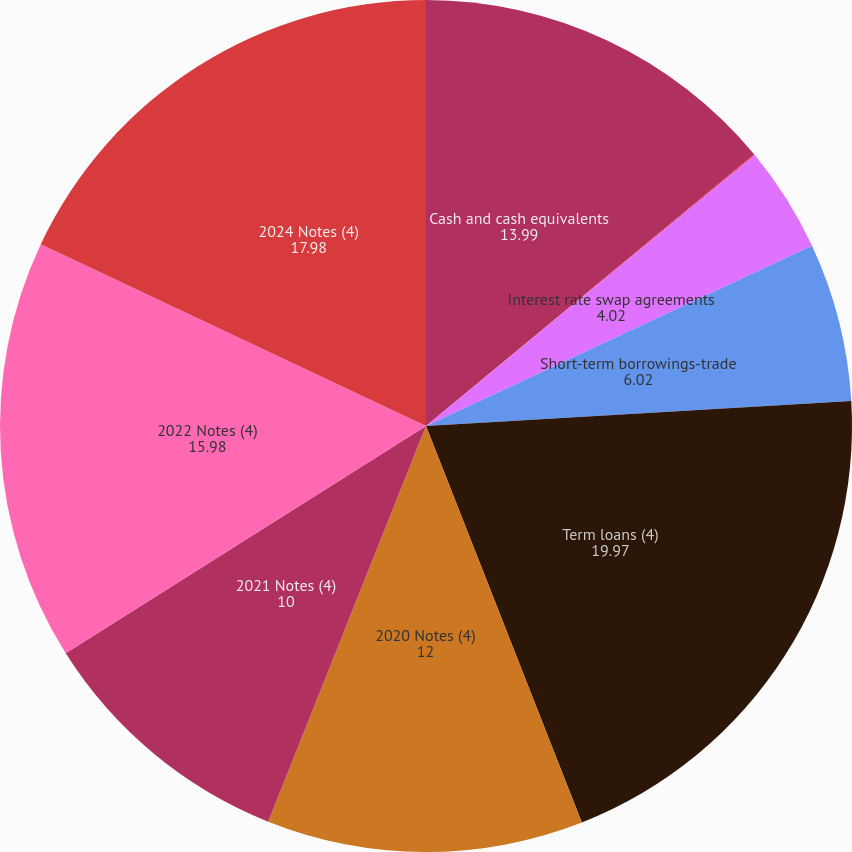Convert chart. <chart><loc_0><loc_0><loc_500><loc_500><pie_chart><fcel>Cash and cash equivalents<fcel>Interest rate cap agreements<fcel>Interest rate swap agreements<fcel>Short-term borrowings-trade<fcel>Term loans (4)<fcel>2020 Notes (4)<fcel>2021 Notes (4)<fcel>2022 Notes (4)<fcel>2024 Notes (4)<nl><fcel>13.99%<fcel>0.04%<fcel>4.02%<fcel>6.02%<fcel>19.97%<fcel>12.0%<fcel>10.0%<fcel>15.98%<fcel>17.98%<nl></chart> 